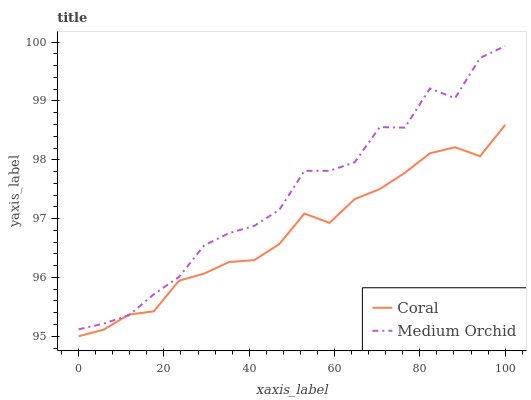Does Coral have the minimum area under the curve?
Answer yes or no. Yes. Does Medium Orchid have the maximum area under the curve?
Answer yes or no. Yes. Does Medium Orchid have the minimum area under the curve?
Answer yes or no. No. Is Coral the smoothest?
Answer yes or no. Yes. Is Medium Orchid the roughest?
Answer yes or no. Yes. Is Medium Orchid the smoothest?
Answer yes or no. No. Does Coral have the lowest value?
Answer yes or no. Yes. Does Medium Orchid have the lowest value?
Answer yes or no. No. Does Medium Orchid have the highest value?
Answer yes or no. Yes. Does Coral intersect Medium Orchid?
Answer yes or no. Yes. Is Coral less than Medium Orchid?
Answer yes or no. No. Is Coral greater than Medium Orchid?
Answer yes or no. No. 